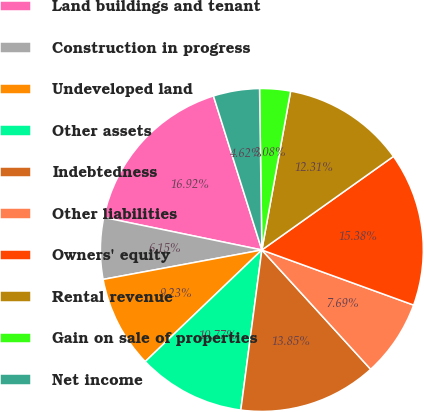Convert chart to OTSL. <chart><loc_0><loc_0><loc_500><loc_500><pie_chart><fcel>Land buildings and tenant<fcel>Construction in progress<fcel>Undeveloped land<fcel>Other assets<fcel>Indebtedness<fcel>Other liabilities<fcel>Owners' equity<fcel>Rental revenue<fcel>Gain on sale of properties<fcel>Net income<nl><fcel>16.92%<fcel>6.15%<fcel>9.23%<fcel>10.77%<fcel>13.85%<fcel>7.69%<fcel>15.38%<fcel>12.31%<fcel>3.08%<fcel>4.62%<nl></chart> 